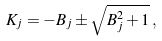Convert formula to latex. <formula><loc_0><loc_0><loc_500><loc_500>K _ { j } = - B _ { j } \pm \sqrt { B _ { j } ^ { 2 } + 1 } \, ,</formula> 